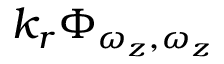<formula> <loc_0><loc_0><loc_500><loc_500>k _ { r } \Phi _ { \omega _ { z } , \omega _ { z } }</formula> 